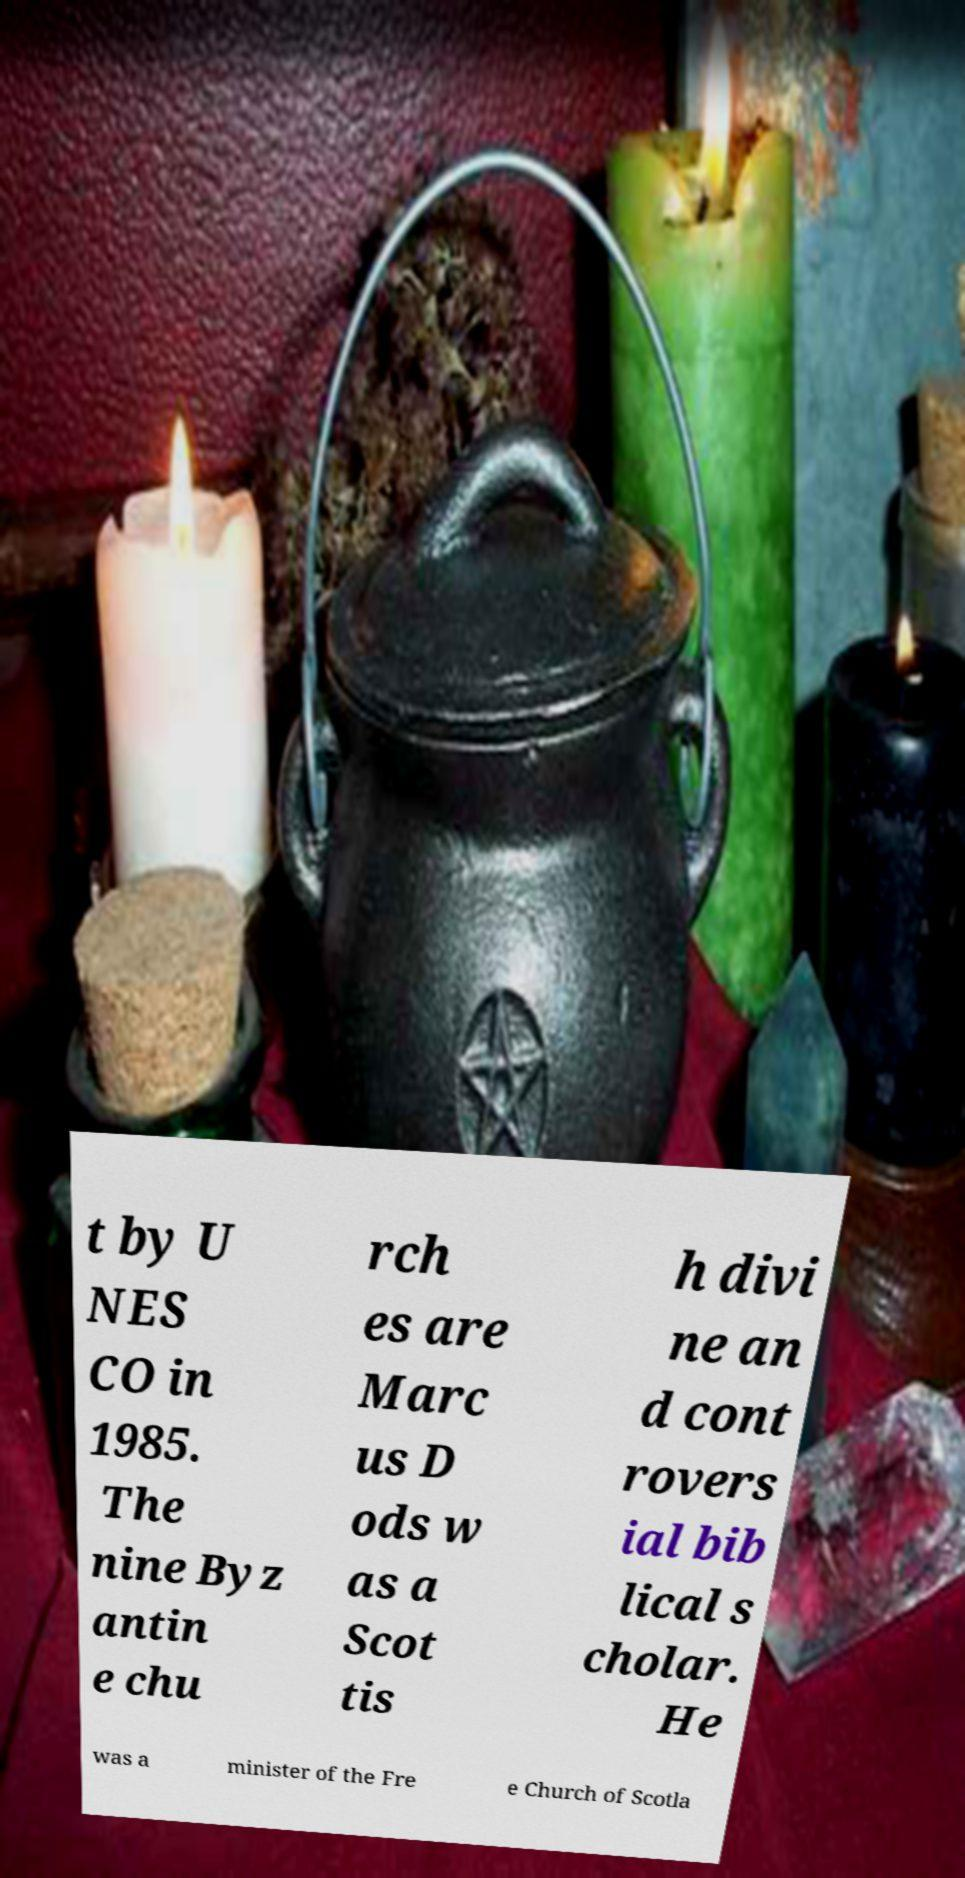Could you extract and type out the text from this image? t by U NES CO in 1985. The nine Byz antin e chu rch es are Marc us D ods w as a Scot tis h divi ne an d cont rovers ial bib lical s cholar. He was a minister of the Fre e Church of Scotla 